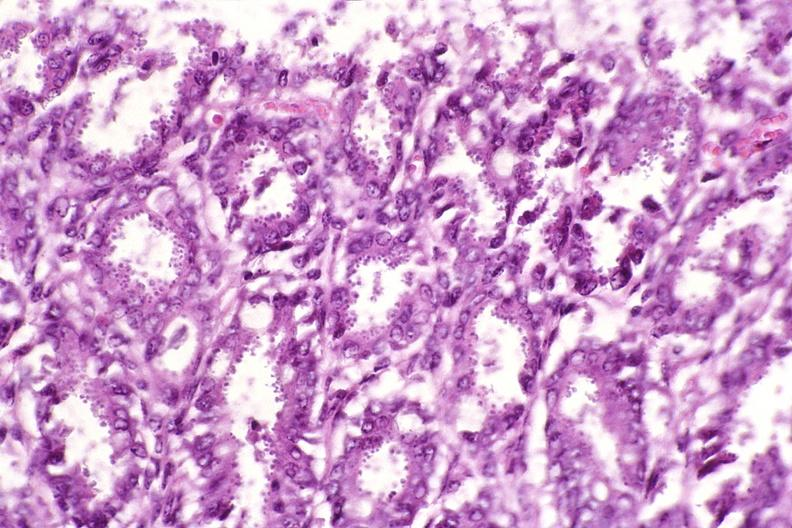s gastrointestinal present?
Answer the question using a single word or phrase. Yes 